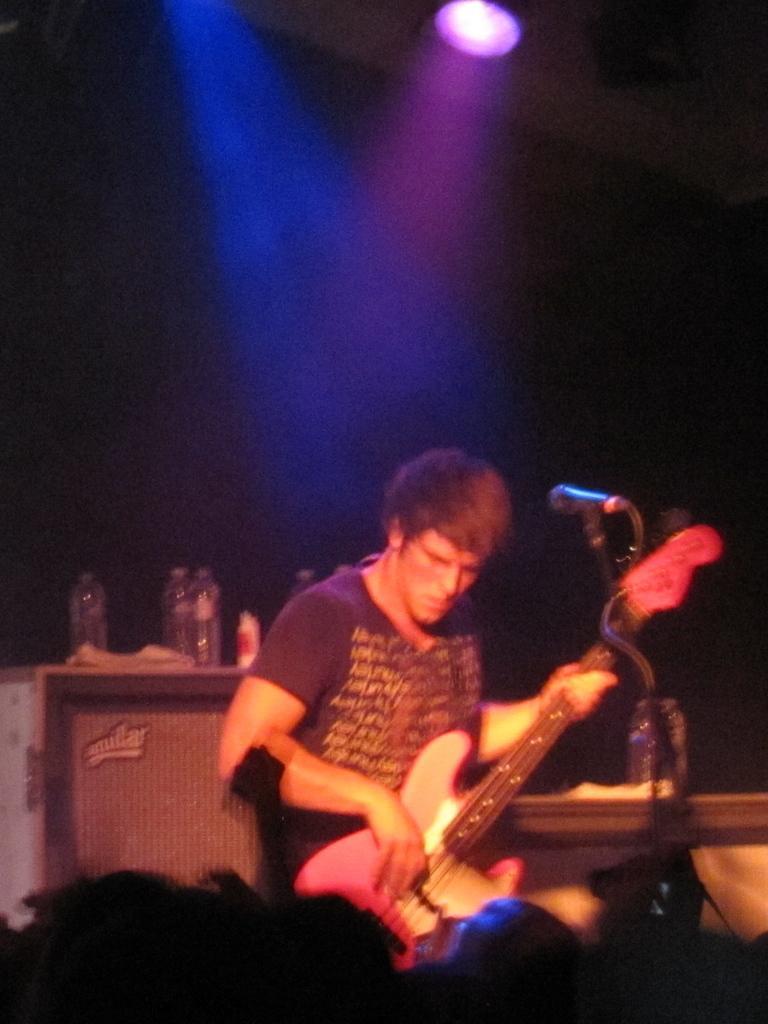In one or two sentences, can you explain what this image depicts? In this image we can see there is the person playing guitar and there is the mic in front of him. And at the back there is the table, on the table there are bottles and paper. And at the top there are lights. 